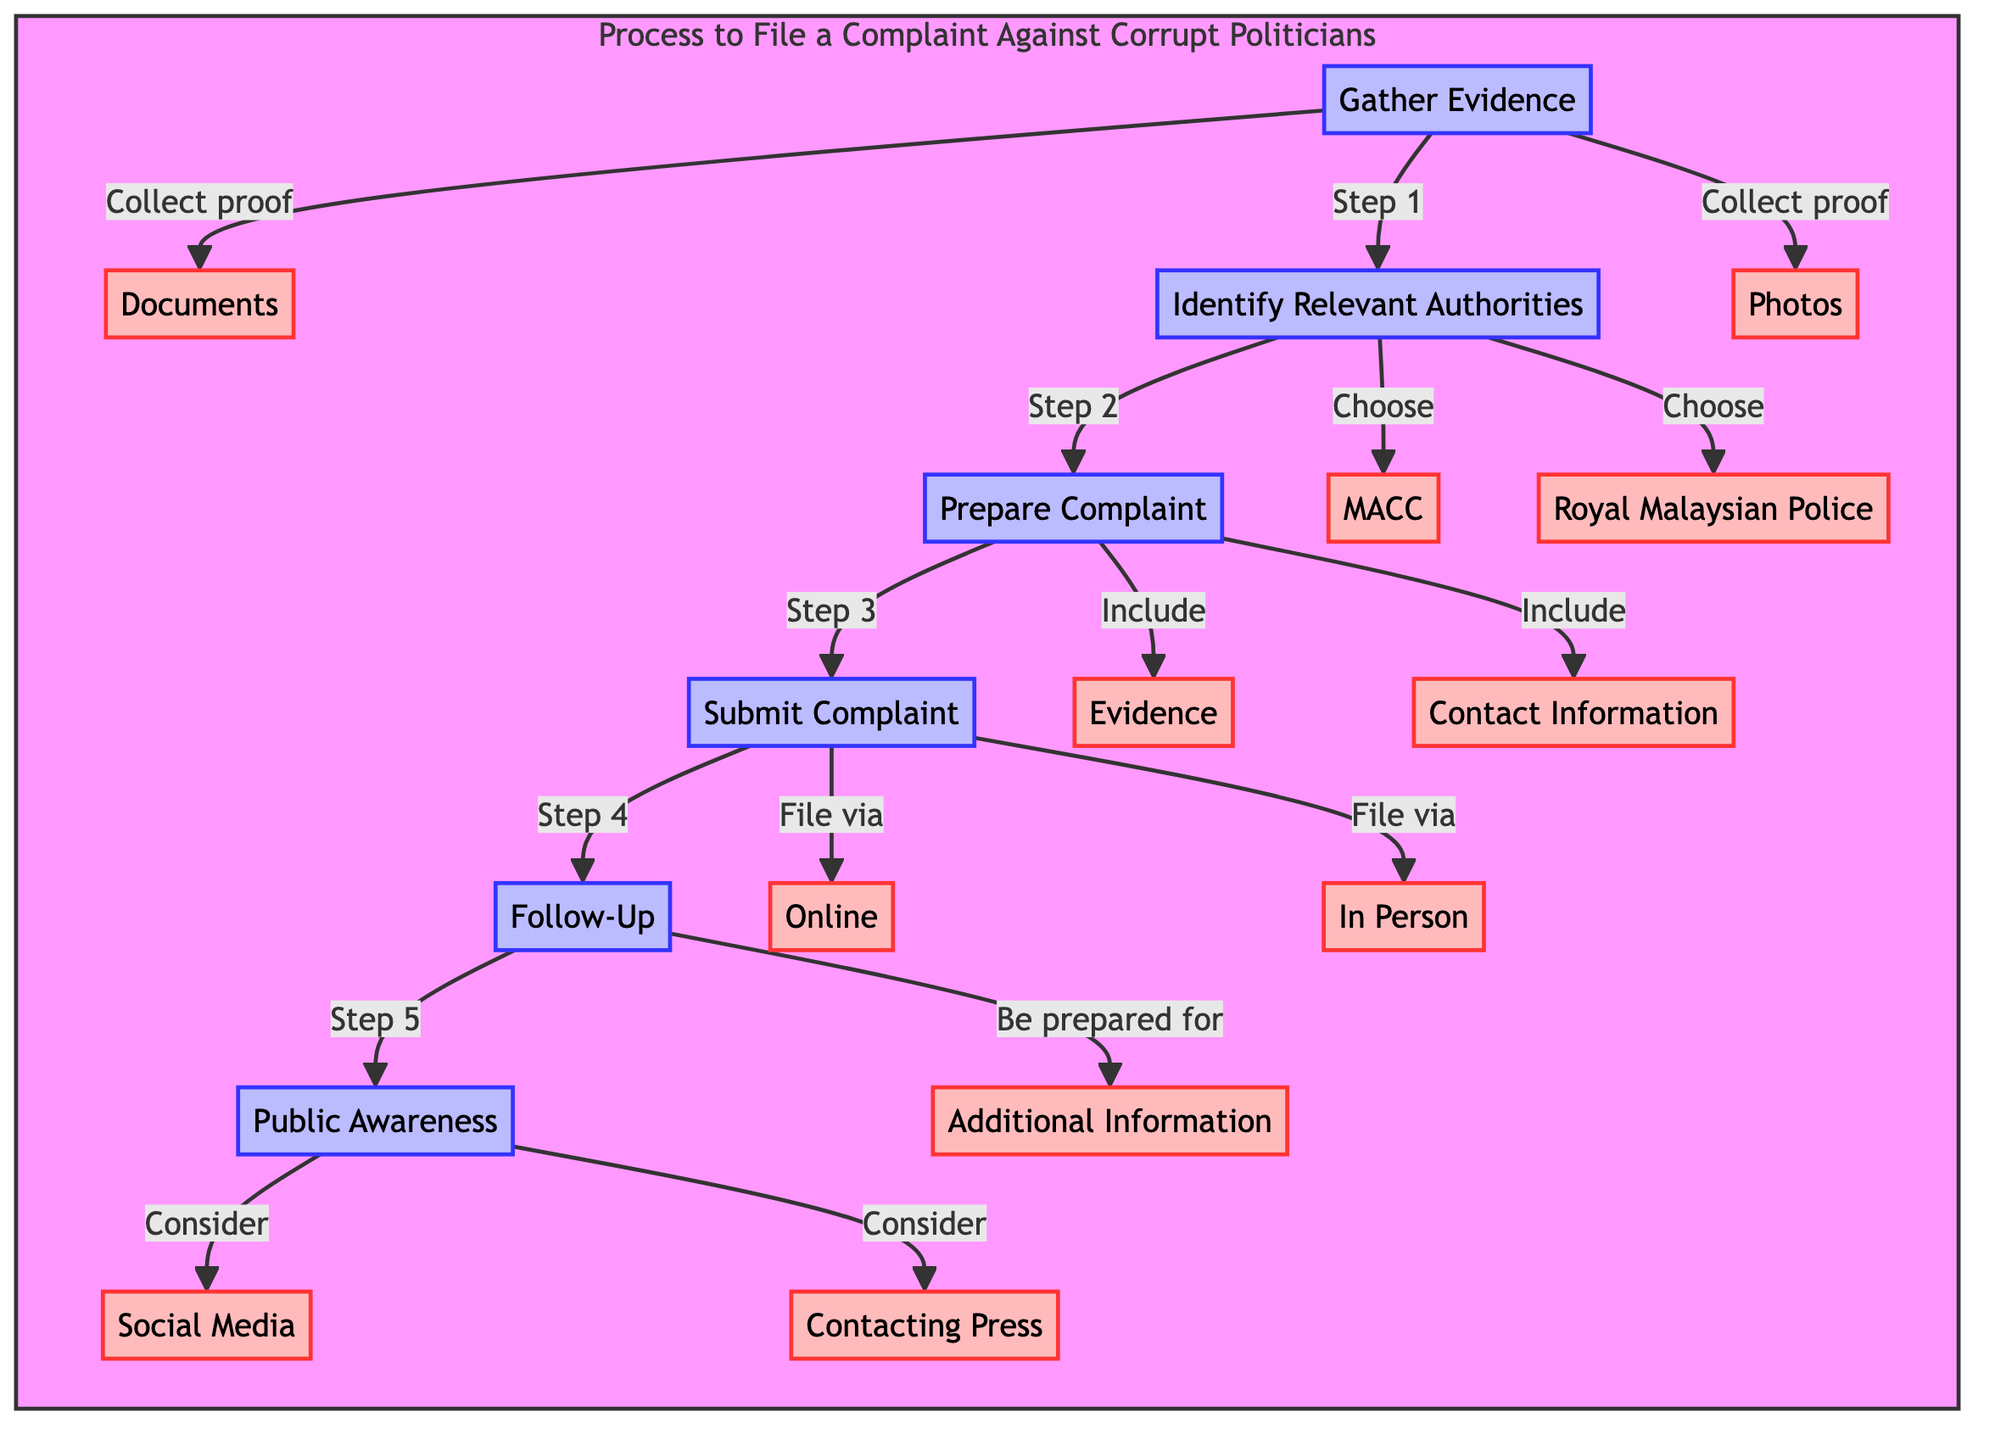What is the first step in the process? The diagram indicates that the first step is "Gather Evidence," which is clearly labeled at the top as Step 1.
Answer: Gather Evidence How many authorities can be identified in the second step? In Step 2, there are two choices listed for relevant authorities: "MACC" and "Royal Malaysian Police." Therefore, the total number of authorities is two.
Answer: 2 What type of documents can be collected as evidence? The specific documents that can be collected as evidence are categorized in the sub-process under "Gather Evidence," including "Documents" and "Photos."
Answer: Documents, Photos What is required to include in the complaint? The diagram specifies that a formal complaint must include "Evidence" and "Contact Information," which are both mentioned under Step 3, "Prepare Complaint."
Answer: Evidence, Contact Information How can a complaint be submitted according to the chart? The chart outlines two methods for submitting a complaint: either "Online" or "In Person," which are found under Step 4.
Answer: Online, In Person What should be done after submitting the complaint? Following the submission, Step 5 directs to "Follow-Up," which emphasizes the importance of maintaining communication with the authorities.
Answer: Follow-Up What public platforms are considered for raising awareness? The diagram under Step 6 mentions "Social Media" and "Contacting Press" as potential platforms for raising public awareness about the complaint.
Answer: Social Media, Contacting Press What step follows “Prepare Complaint”? The flowchart displays “Submit Complaint” as the immediate next step after “Prepare Complaint,” connecting the two actions sequentially.
Answer: Submit Complaint 